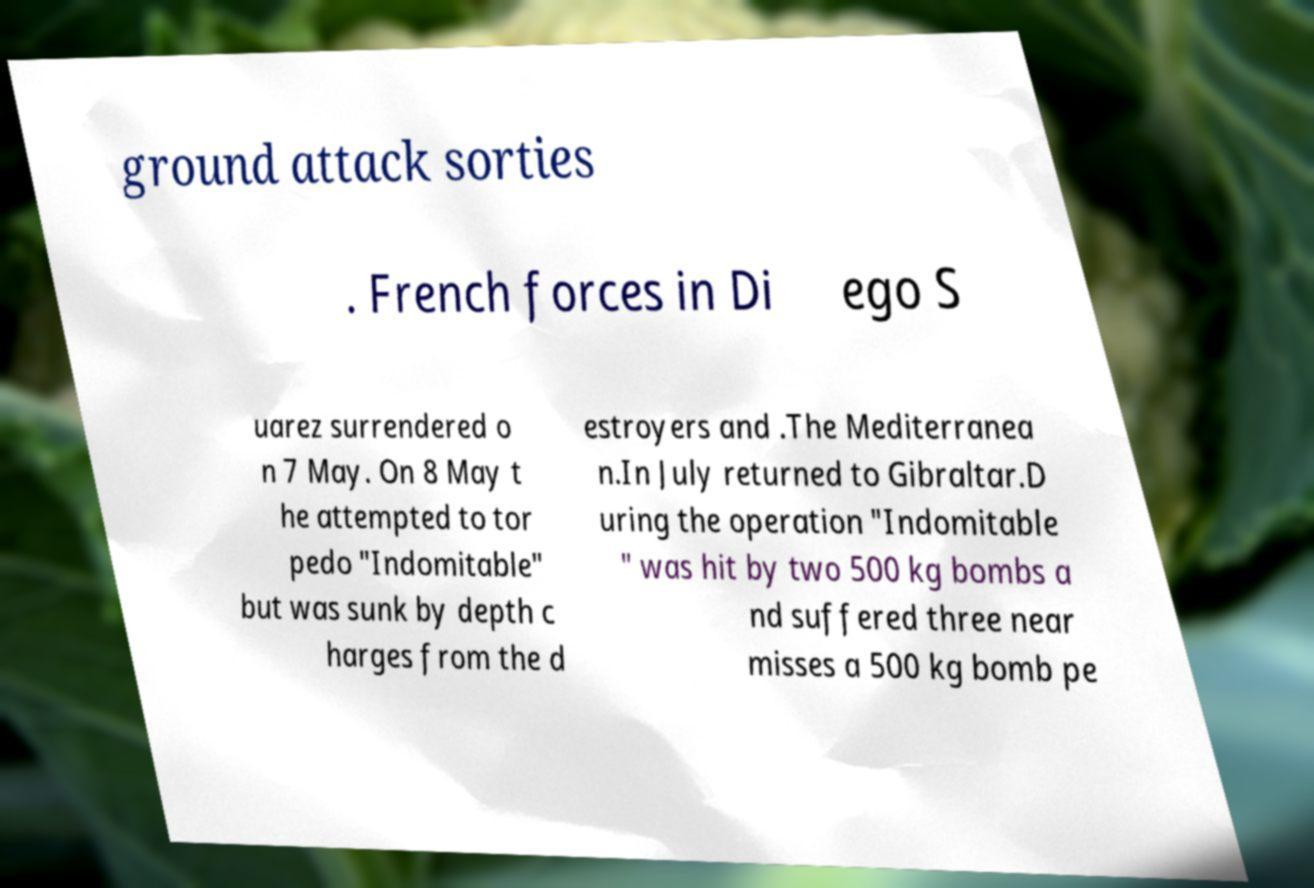Please read and relay the text visible in this image. What does it say? ground attack sorties . French forces in Di ego S uarez surrendered o n 7 May. On 8 May t he attempted to tor pedo "Indomitable" but was sunk by depth c harges from the d estroyers and .The Mediterranea n.In July returned to Gibraltar.D uring the operation "Indomitable " was hit by two 500 kg bombs a nd suffered three near misses a 500 kg bomb pe 